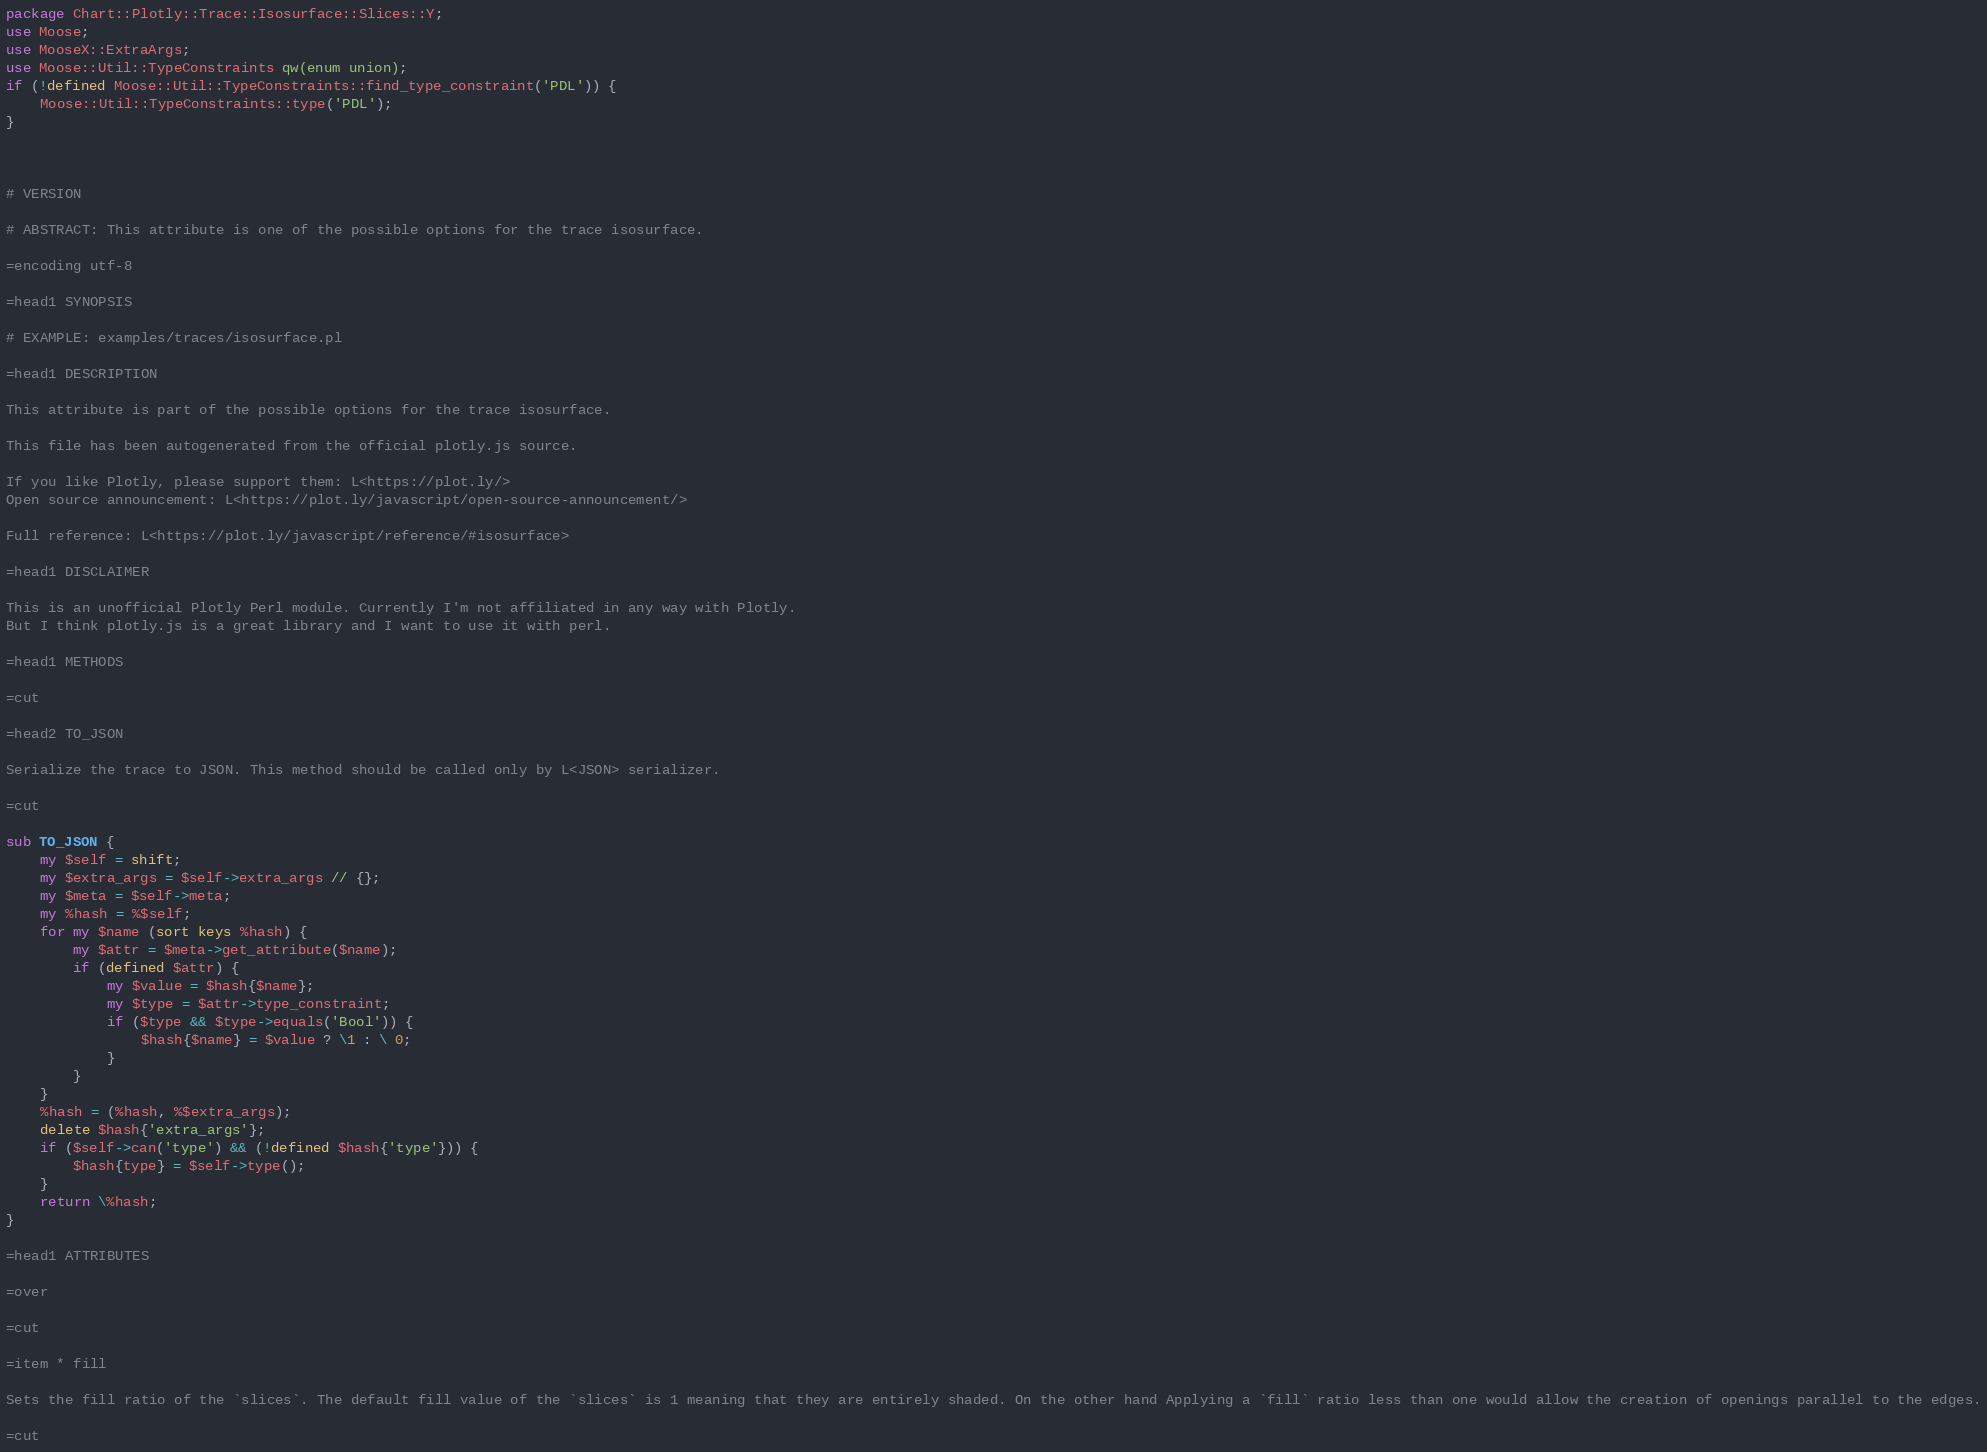Convert code to text. <code><loc_0><loc_0><loc_500><loc_500><_Perl_>package Chart::Plotly::Trace::Isosurface::Slices::Y;
use Moose;
use MooseX::ExtraArgs;
use Moose::Util::TypeConstraints qw(enum union);
if (!defined Moose::Util::TypeConstraints::find_type_constraint('PDL')) {
    Moose::Util::TypeConstraints::type('PDL');
}



# VERSION

# ABSTRACT: This attribute is one of the possible options for the trace isosurface.

=encoding utf-8

=head1 SYNOPSIS

# EXAMPLE: examples/traces/isosurface.pl

=head1 DESCRIPTION

This attribute is part of the possible options for the trace isosurface.

This file has been autogenerated from the official plotly.js source.

If you like Plotly, please support them: L<https://plot.ly/> 
Open source announcement: L<https://plot.ly/javascript/open-source-announcement/>

Full reference: L<https://plot.ly/javascript/reference/#isosurface>

=head1 DISCLAIMER

This is an unofficial Plotly Perl module. Currently I'm not affiliated in any way with Plotly. 
But I think plotly.js is a great library and I want to use it with perl.

=head1 METHODS

=cut

=head2 TO_JSON

Serialize the trace to JSON. This method should be called only by L<JSON> serializer.

=cut

sub TO_JSON {
    my $self = shift; 
    my $extra_args = $self->extra_args // {};
    my $meta = $self->meta;
    my %hash = %$self;
    for my $name (sort keys %hash) {
        my $attr = $meta->get_attribute($name);
        if (defined $attr) {
            my $value = $hash{$name};
            my $type = $attr->type_constraint;
            if ($type && $type->equals('Bool')) {
                $hash{$name} = $value ? \1 : \ 0;
            }
        }
    }
    %hash = (%hash, %$extra_args);
    delete $hash{'extra_args'};
    if ($self->can('type') && (!defined $hash{'type'})) {
        $hash{type} = $self->type();
    }
    return \%hash;
}

=head1 ATTRIBUTES

=over

=cut

=item * fill

Sets the fill ratio of the `slices`. The default fill value of the `slices` is 1 meaning that they are entirely shaded. On the other hand Applying a `fill` ratio less than one would allow the creation of openings parallel to the edges.

=cut
</code> 